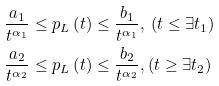<formula> <loc_0><loc_0><loc_500><loc_500>\frac { a _ { 1 } } { t ^ { \alpha _ { 1 } } } & \leq p _ { L } \left ( t \right ) \leq \frac { b _ { 1 } } { t ^ { \alpha _ { 1 } } } , \, \left ( t \leq \exists t _ { 1 } \right ) \\ \frac { a _ { 2 } } { t ^ { \alpha _ { 2 } } } & \leq p _ { L } \left ( t \right ) \leq \frac { b _ { 2 } } { t ^ { \alpha _ { 2 } } } , \left ( t \geq \exists t _ { 2 } \right )</formula> 